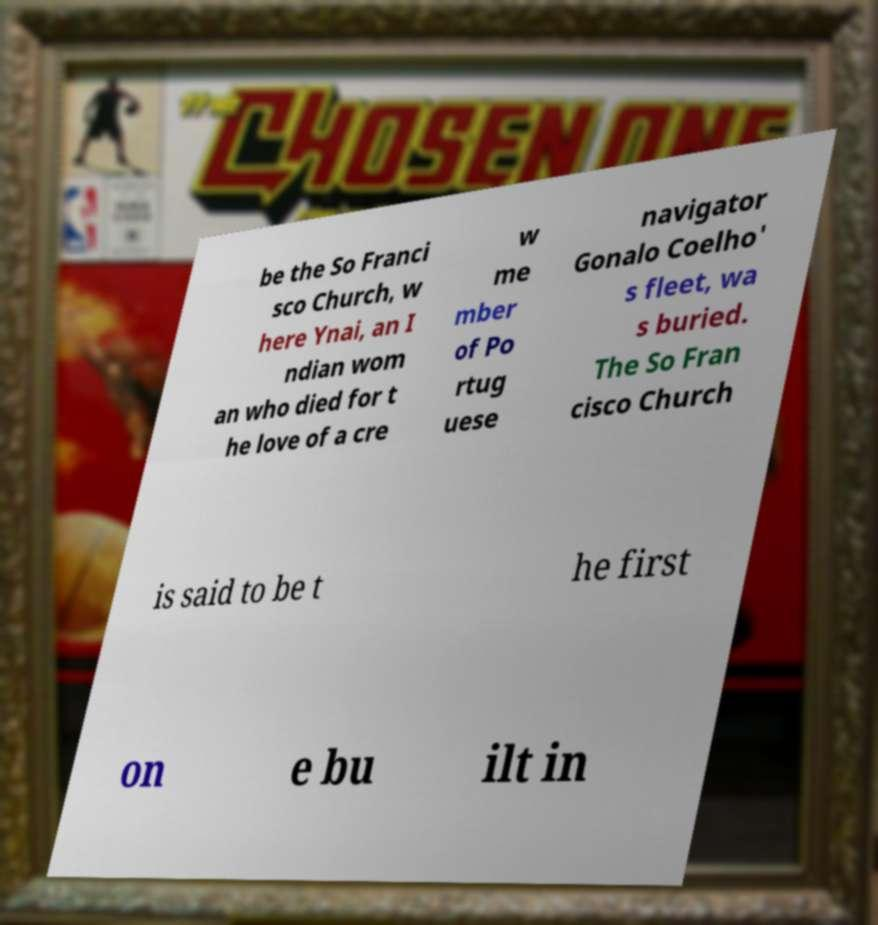Could you extract and type out the text from this image? be the So Franci sco Church, w here Ynai, an I ndian wom an who died for t he love of a cre w me mber of Po rtug uese navigator Gonalo Coelho' s fleet, wa s buried. The So Fran cisco Church is said to be t he first on e bu ilt in 